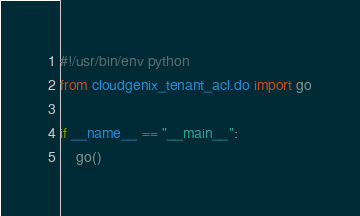<code> <loc_0><loc_0><loc_500><loc_500><_Python_>#!/usr/bin/env python
from cloudgenix_tenant_acl.do import go

if __name__ == "__main__":
    go()
</code> 